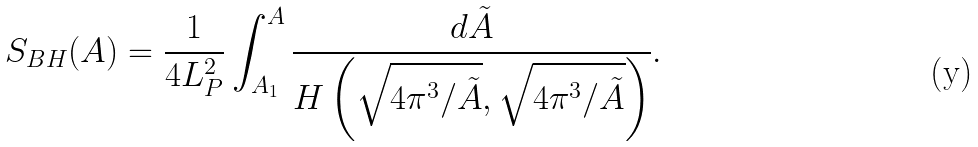<formula> <loc_0><loc_0><loc_500><loc_500>S _ { B H } ( A ) = \frac { 1 } { 4 L _ { P } ^ { 2 } } \int _ { A _ { 1 } } ^ { A } \frac { d \tilde { A } } { H \left ( \sqrt { 4 \pi ^ { 3 } / \tilde { A } } , \sqrt { 4 \pi ^ { 3 } / \tilde { A } } \right ) } .</formula> 